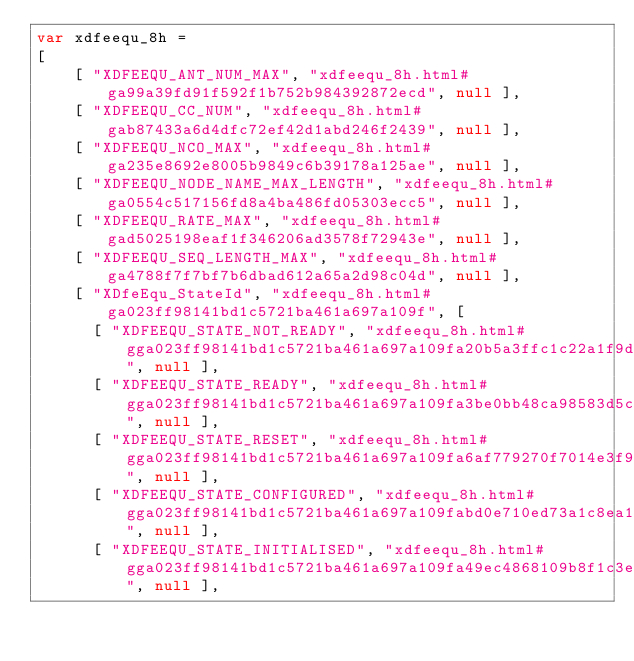Convert code to text. <code><loc_0><loc_0><loc_500><loc_500><_JavaScript_>var xdfeequ_8h =
[
    [ "XDFEEQU_ANT_NUM_MAX", "xdfeequ_8h.html#ga99a39fd91f592f1b752b984392872ecd", null ],
    [ "XDFEEQU_CC_NUM", "xdfeequ_8h.html#gab87433a6d4dfc72ef42d1abd246f2439", null ],
    [ "XDFEEQU_NCO_MAX", "xdfeequ_8h.html#ga235e8692e8005b9849c6b39178a125ae", null ],
    [ "XDFEEQU_NODE_NAME_MAX_LENGTH", "xdfeequ_8h.html#ga0554c517156fd8a4ba486fd05303ecc5", null ],
    [ "XDFEEQU_RATE_MAX", "xdfeequ_8h.html#gad5025198eaf1f346206ad3578f72943e", null ],
    [ "XDFEEQU_SEQ_LENGTH_MAX", "xdfeequ_8h.html#ga4788f7f7bf7b6dbad612a65a2d98c04d", null ],
    [ "XDfeEqu_StateId", "xdfeequ_8h.html#ga023ff98141bd1c5721ba461a697a109f", [
      [ "XDFEEQU_STATE_NOT_READY", "xdfeequ_8h.html#gga023ff98141bd1c5721ba461a697a109fa20b5a3ffc1c22a1f9d0bae0db1c6fe77", null ],
      [ "XDFEEQU_STATE_READY", "xdfeequ_8h.html#gga023ff98141bd1c5721ba461a697a109fa3be0bb48ca98583d5c9ea76534cf9825", null ],
      [ "XDFEEQU_STATE_RESET", "xdfeequ_8h.html#gga023ff98141bd1c5721ba461a697a109fa6af779270f7014e3f99a4c7a9e3d1a45", null ],
      [ "XDFEEQU_STATE_CONFIGURED", "xdfeequ_8h.html#gga023ff98141bd1c5721ba461a697a109fabd0e710ed73a1c8ea158301ddf96e4a8", null ],
      [ "XDFEEQU_STATE_INITIALISED", "xdfeequ_8h.html#gga023ff98141bd1c5721ba461a697a109fa49ec4868109b8f1c3e286e92070d5e61", null ],</code> 